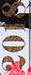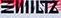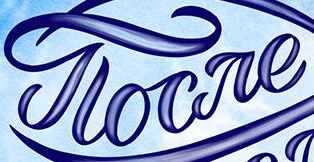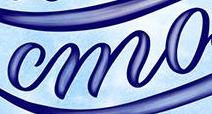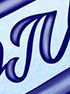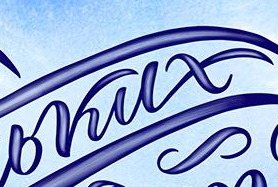What words are shown in these images in order, separated by a semicolon? 2018; ΞIIIILTZ; gloare; mo; #; bkux 